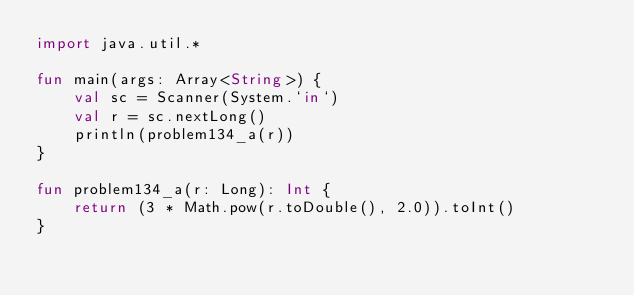Convert code to text. <code><loc_0><loc_0><loc_500><loc_500><_Kotlin_>import java.util.*

fun main(args: Array<String>) {
    val sc = Scanner(System.`in`)
    val r = sc.nextLong()
    println(problem134_a(r))
}

fun problem134_a(r: Long): Int {
    return (3 * Math.pow(r.toDouble(), 2.0)).toInt()
}</code> 